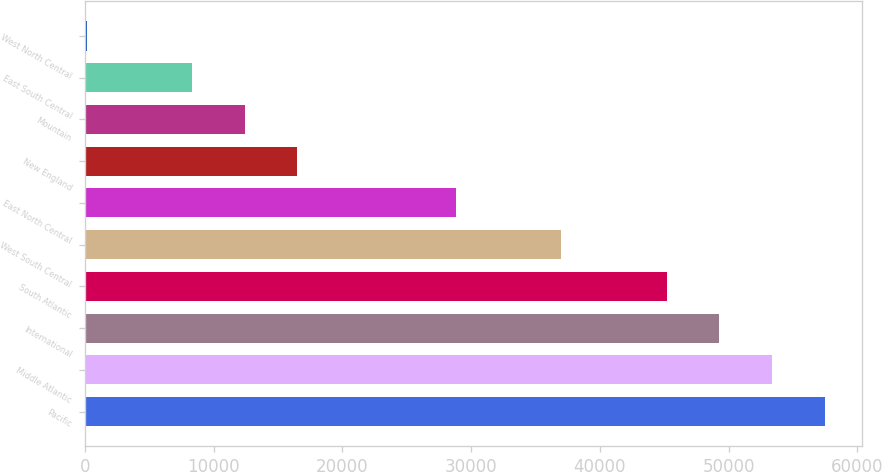<chart> <loc_0><loc_0><loc_500><loc_500><bar_chart><fcel>Pacific<fcel>Middle Atlantic<fcel>International<fcel>South Atlantic<fcel>West South Central<fcel>East North Central<fcel>New England<fcel>Mountain<fcel>East South Central<fcel>West North Central<nl><fcel>57467.2<fcel>53372.4<fcel>49277.6<fcel>45182.8<fcel>36993.2<fcel>28803.6<fcel>16519.2<fcel>12424.4<fcel>8329.6<fcel>140<nl></chart> 